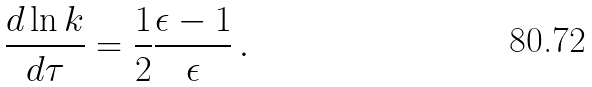<formula> <loc_0><loc_0><loc_500><loc_500>\frac { d \ln k } { d \tau } = \frac { 1 } { 2 } \frac { \epsilon - 1 } { \epsilon } \, .</formula> 